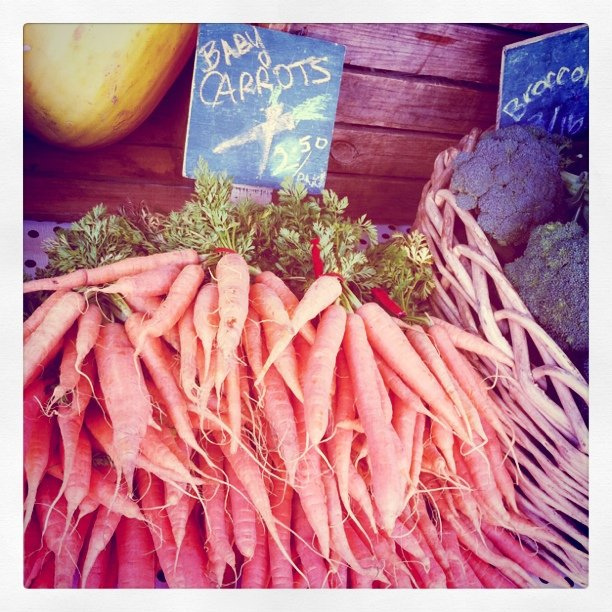What type of carrots are they? The visible sign reads 'baby carrots,' indicating that these are young, small carrots typically sweeter and more tender than fully-grown varieties. 